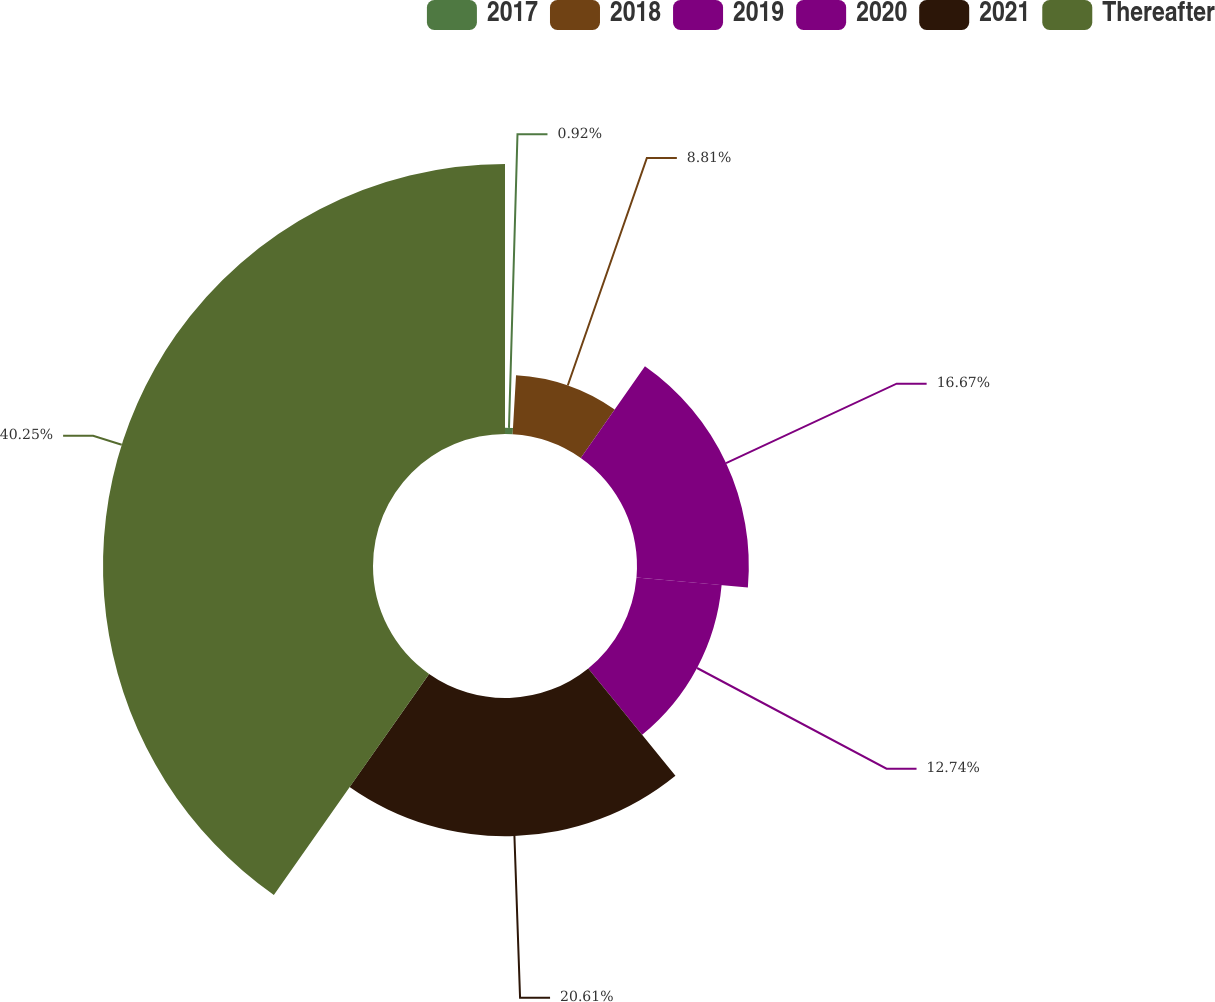Convert chart. <chart><loc_0><loc_0><loc_500><loc_500><pie_chart><fcel>2017<fcel>2018<fcel>2019<fcel>2020<fcel>2021<fcel>Thereafter<nl><fcel>0.92%<fcel>8.81%<fcel>16.67%<fcel>12.74%<fcel>20.61%<fcel>40.25%<nl></chart> 